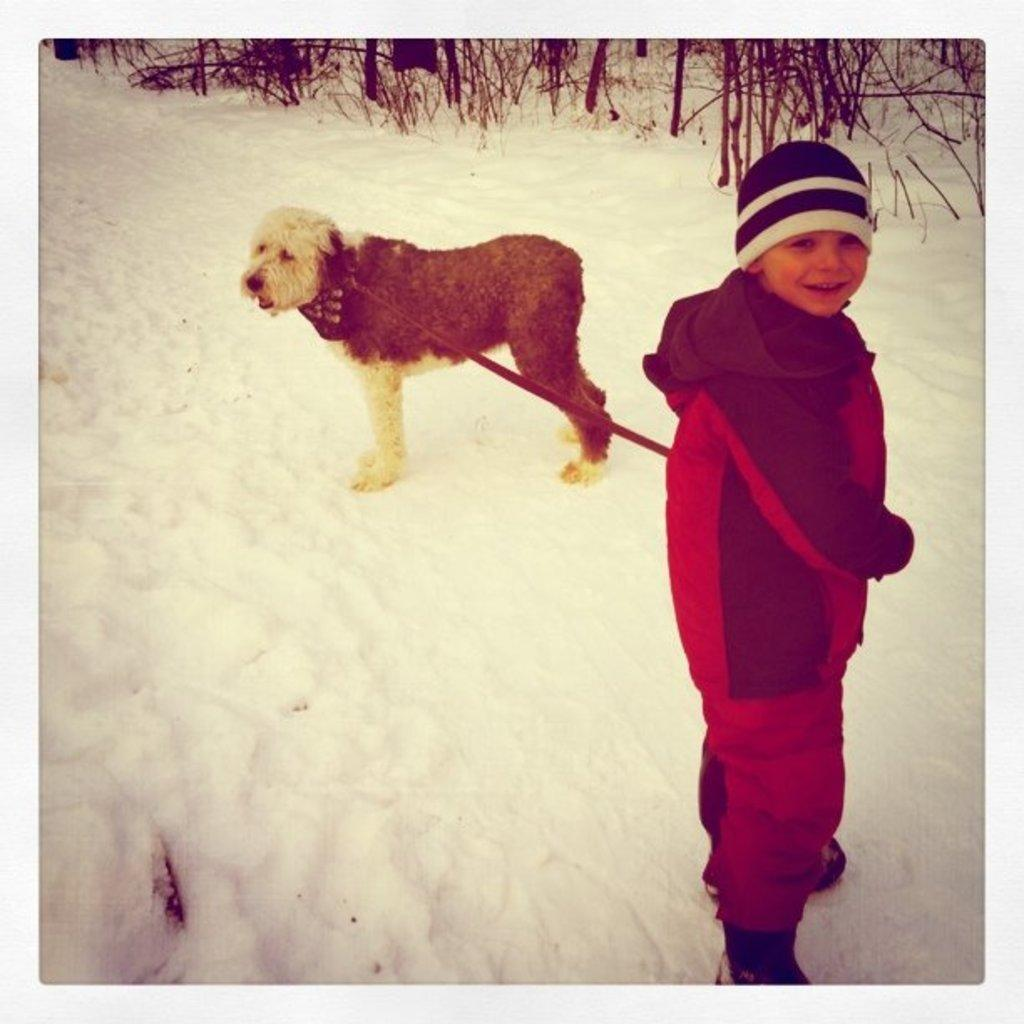Who is present in the image? There is a boy in the image. What is the boy holding? The boy is holding a dog. What is the setting of the image? The scene takes place in the snow. What type of vegetation can be seen in the image? There are plants visible in the image. What color is the basketball in the image? There is no basketball present in the image. Can you describe the veins in the dog's paw in the image? The image does not show the dog's paw or any veins in it. 